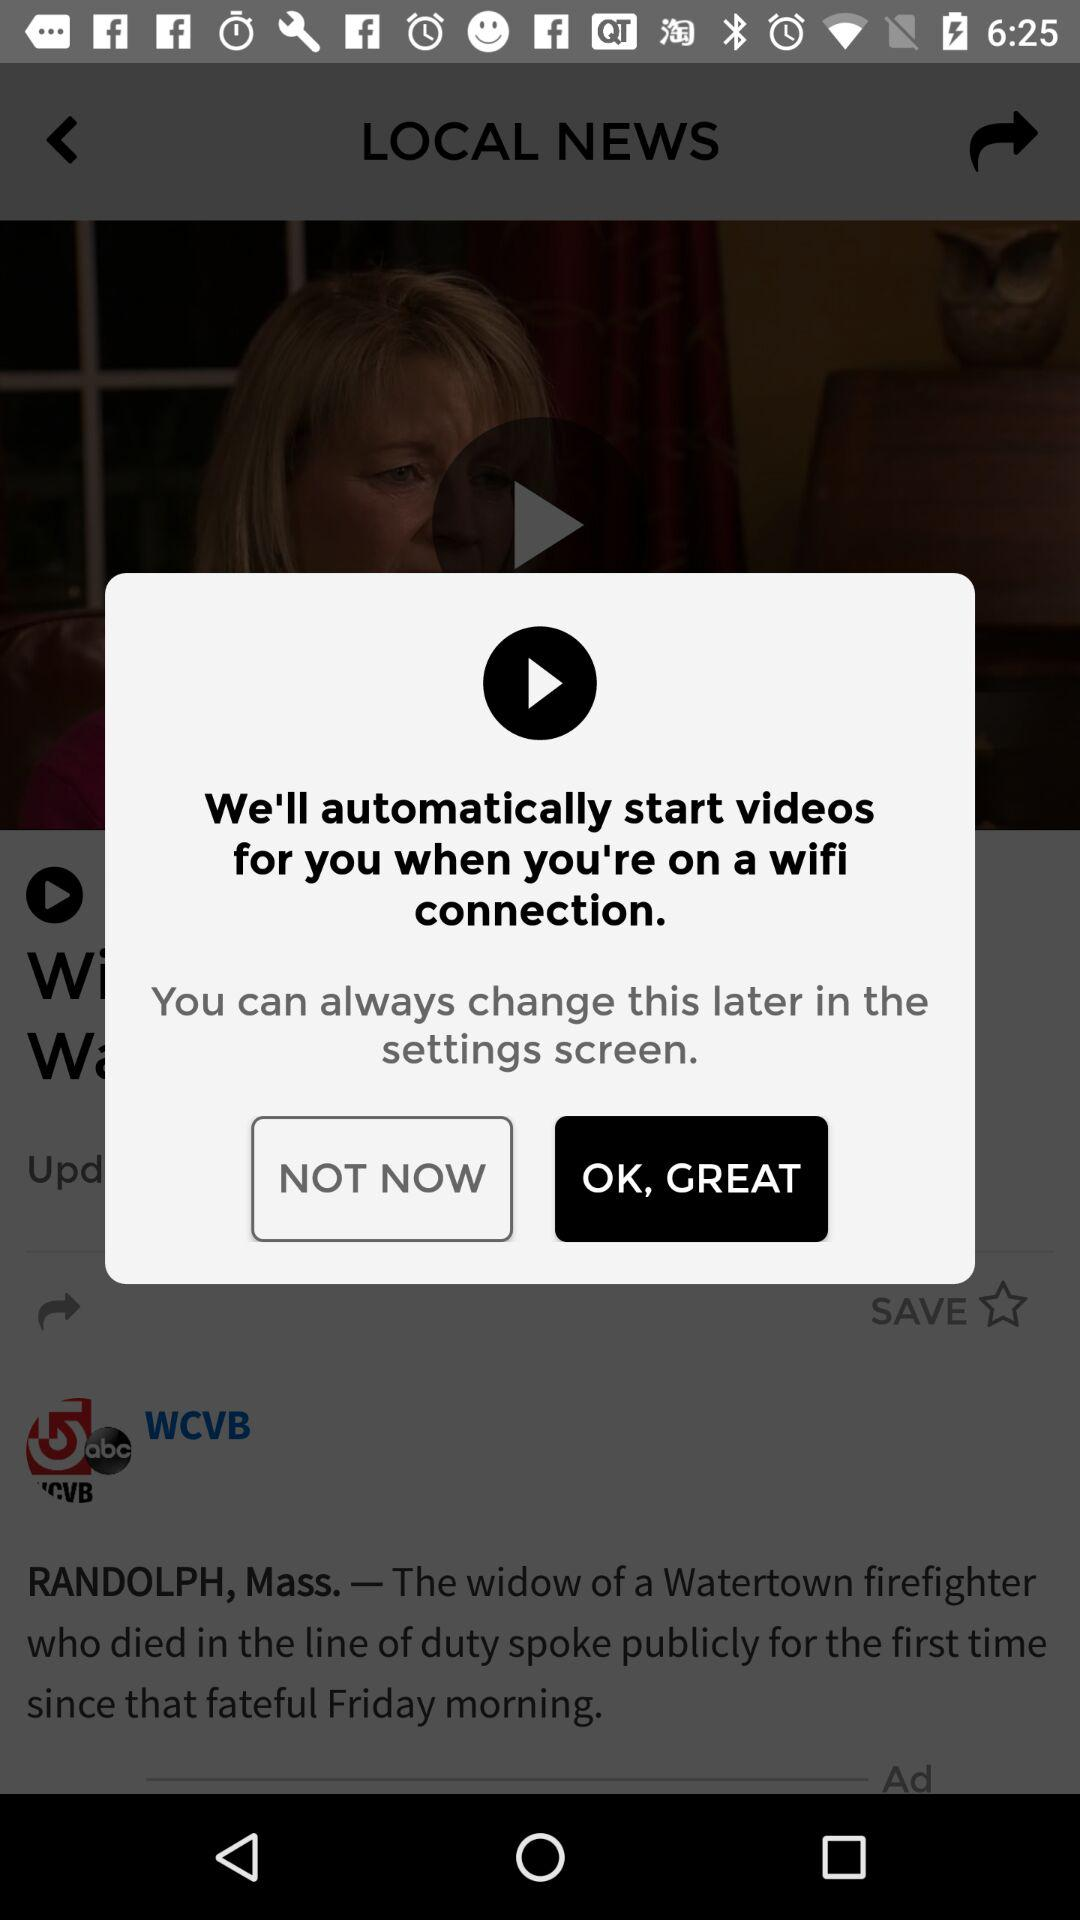When will the video automatically start? The video will automatically start when you are on a wifi connection. 